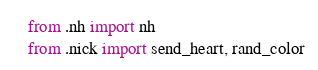<code> <loc_0><loc_0><loc_500><loc_500><_Python_>from .nh import nh
from .nick import send_heart, rand_color
</code> 